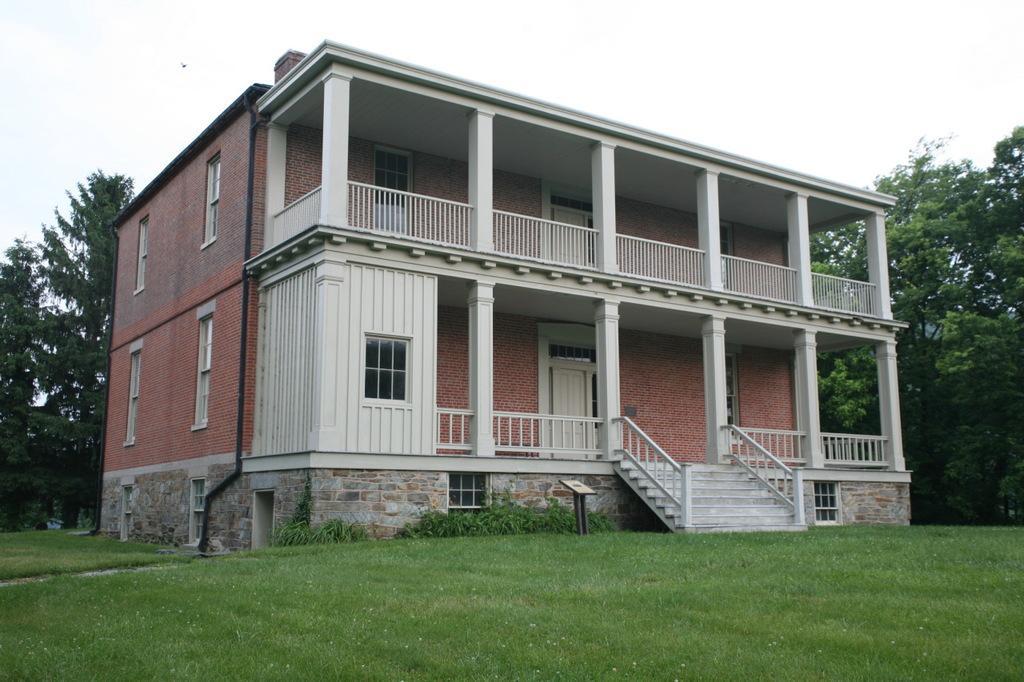Can you describe this image briefly? In the center of the image there is a house. At the bottom there is a grass. In the background we can see trees, sky and clouds. 